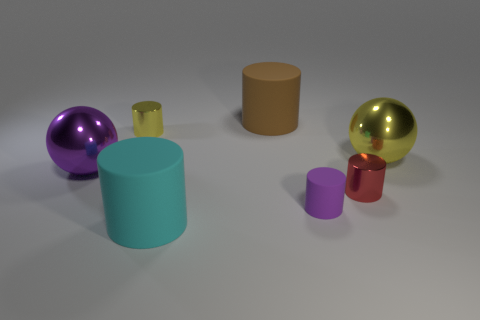Subtract 2 cylinders. How many cylinders are left? 3 Subtract all cyan cylinders. How many cylinders are left? 4 Subtract all purple cylinders. How many cylinders are left? 4 Subtract all blue cylinders. Subtract all blue balls. How many cylinders are left? 5 Add 2 objects. How many objects exist? 9 Subtract all spheres. How many objects are left? 5 Subtract all small yellow metal spheres. Subtract all large metallic objects. How many objects are left? 5 Add 7 metallic cylinders. How many metallic cylinders are left? 9 Add 4 small red cylinders. How many small red cylinders exist? 5 Subtract 1 cyan cylinders. How many objects are left? 6 